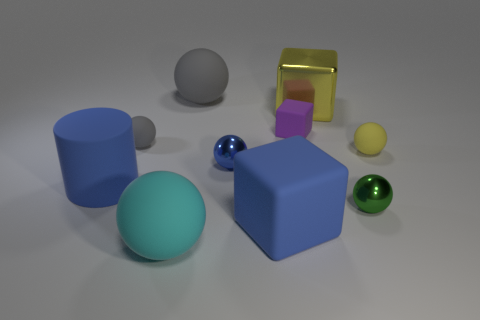Is the number of cylinders on the right side of the cyan thing greater than the number of small red rubber balls?
Your answer should be compact. No. There is a big metallic object; how many metallic balls are right of it?
Provide a short and direct response. 1. The large object that is the same color as the cylinder is what shape?
Provide a short and direct response. Cube. There is a large matte thing in front of the large blue object in front of the tiny green thing; is there a small block that is in front of it?
Offer a terse response. No. Is the size of the green shiny sphere the same as the blue matte cube?
Your answer should be very brief. No. Is the number of big cyan matte balls on the left side of the big cyan rubber object the same as the number of metal blocks that are in front of the big metal cube?
Keep it short and to the point. Yes. What is the shape of the blue matte thing on the right side of the large cyan object?
Your answer should be very brief. Cube. There is a green thing that is the same size as the purple rubber object; what shape is it?
Offer a terse response. Sphere. The matte ball that is in front of the rubber sphere that is to the right of the small metallic ball that is on the left side of the big yellow thing is what color?
Give a very brief answer. Cyan. Is the shape of the big metallic object the same as the cyan thing?
Provide a short and direct response. No. 